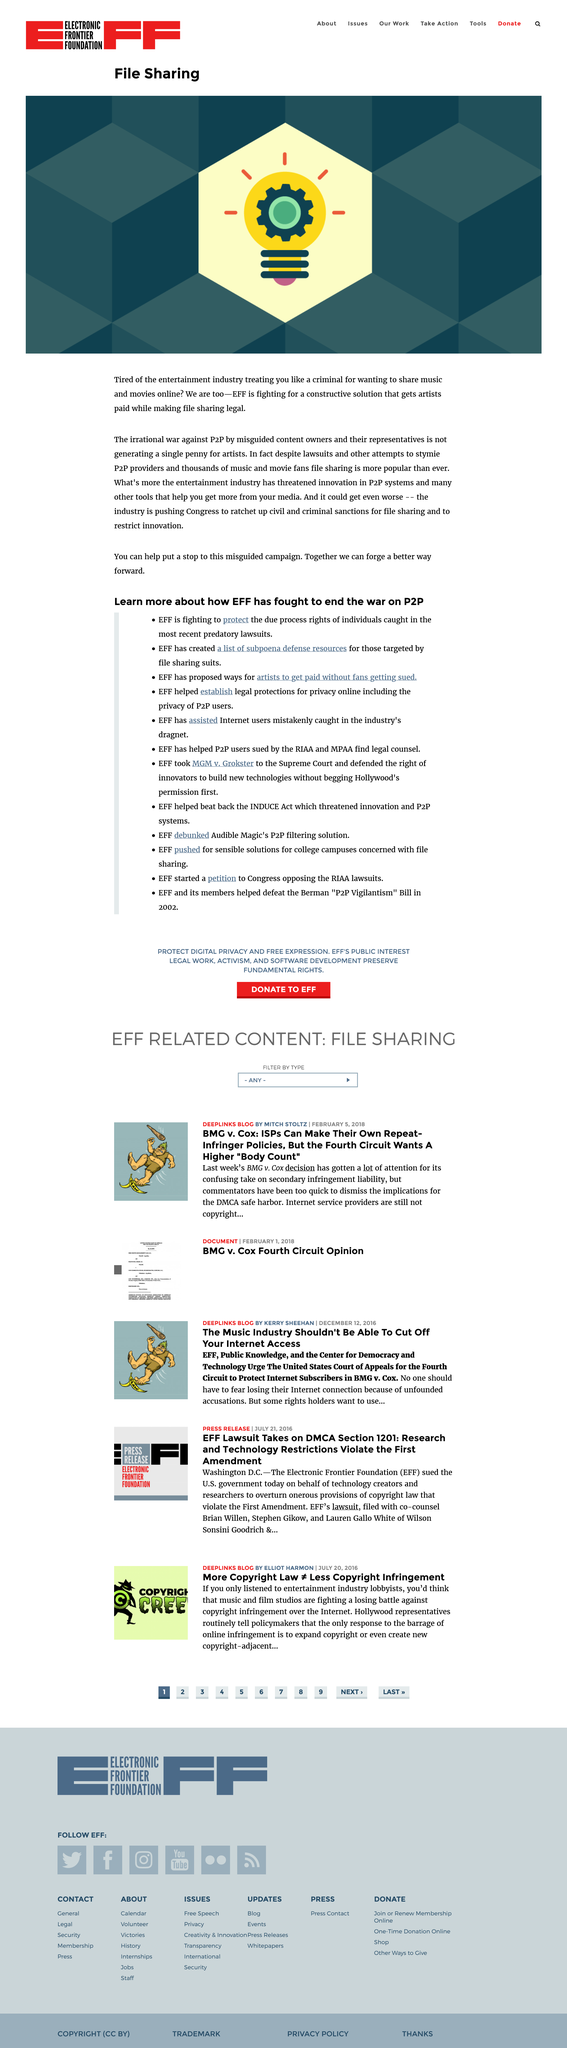Identify some key points in this picture. The war against P2P was described as irrational. This page is about the topic of File Sharing. EFF is the name of the company involved in this matter. 